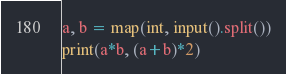Convert code to text. <code><loc_0><loc_0><loc_500><loc_500><_Python_>a, b = map(int, input().split())
print(a*b, (a+b)*2)</code> 